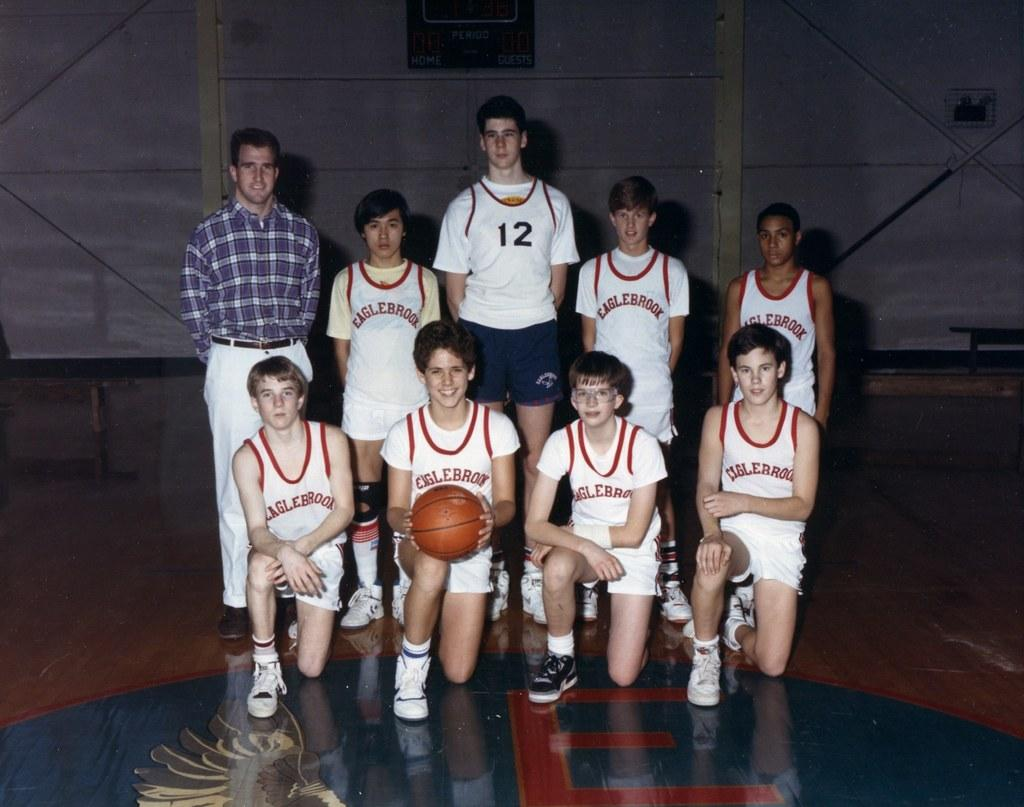<image>
Summarize the visual content of the image. Basketball players wearing an EAGLEBROOK jersey posing for a photo. 